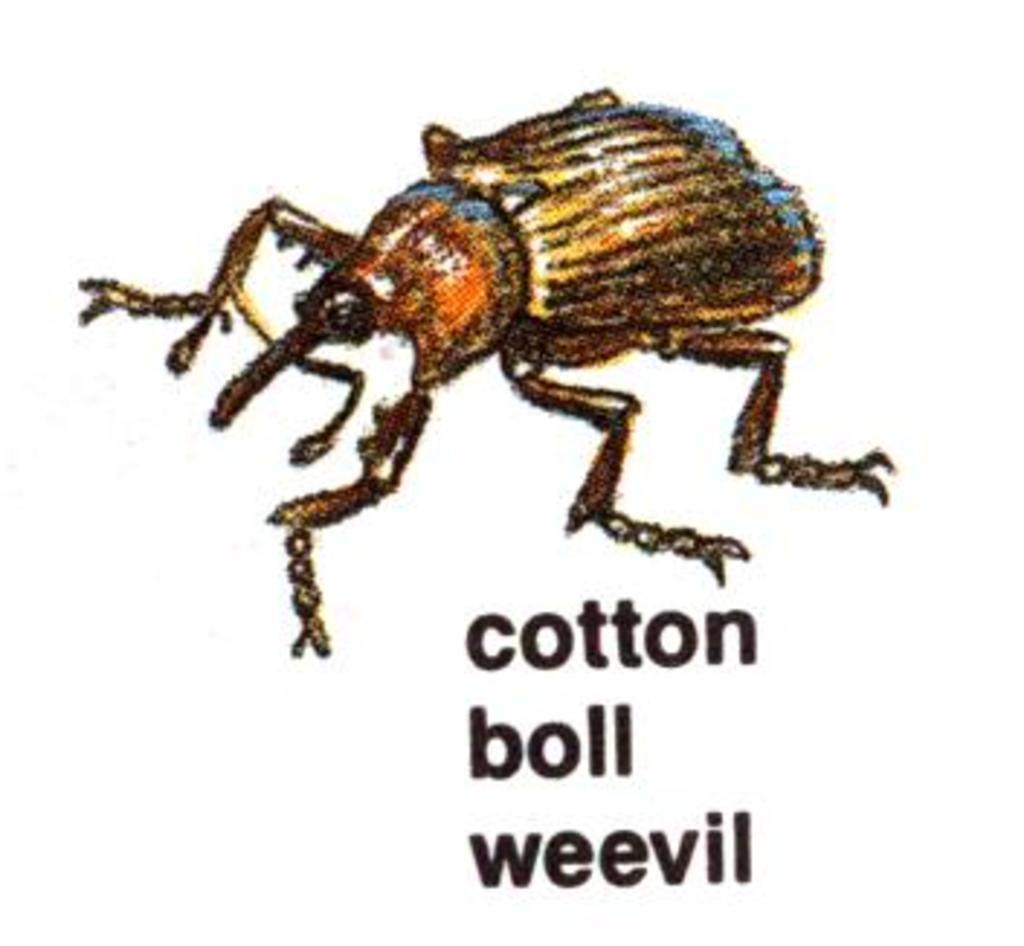Please provide a concise description of this image. In this image there is an art of a insect, and there is a name of the insect. 